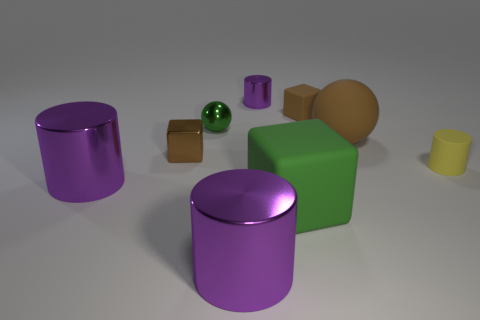How many big things are the same color as the tiny shiny ball?
Provide a short and direct response. 1. How many tiny cylinders are made of the same material as the small green sphere?
Provide a short and direct response. 1. How many objects are either green metallic objects or green things that are in front of the matte sphere?
Offer a very short reply. 2. What color is the small cylinder to the right of the purple object behind the small cylinder right of the brown matte block?
Offer a terse response. Yellow. How big is the brown object that is in front of the brown ball?
Give a very brief answer. Small. What number of large objects are either green matte objects or matte balls?
Your answer should be very brief. 2. What is the color of the tiny thing that is in front of the small sphere and left of the big green matte block?
Give a very brief answer. Brown. Are there any big green rubber objects that have the same shape as the small green thing?
Make the answer very short. No. What is the small green sphere made of?
Ensure brevity in your answer.  Metal. Are there any small metal things behind the brown shiny block?
Give a very brief answer. Yes. 